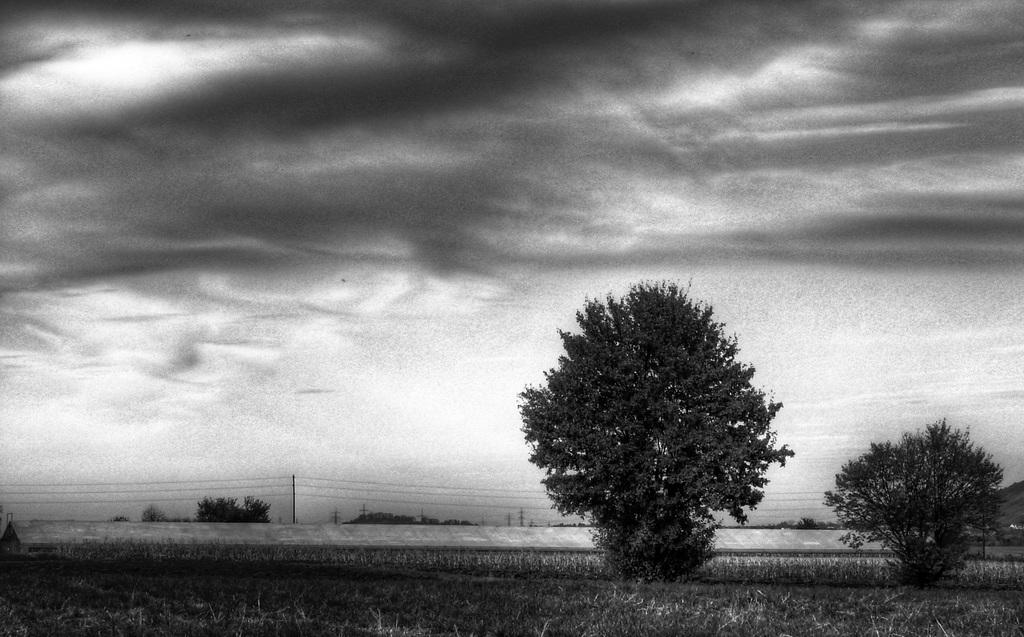What is the color scheme of the image? The image is black and white. What type of natural elements can be seen in the image? There are trees in the image. What man-made structures are present in the image? There are poles and wires in the image. What is the ground like in the image? The ground is visible in the image, and there is grass on it. What part of the natural environment is visible in the image? The sky is visible in the image, and there are clouds in it. How much salt can be seen on the trees in the image? There is no salt present on the trees in the image, as it is a black and white image of trees, poles, wires, grass, and clouds. 